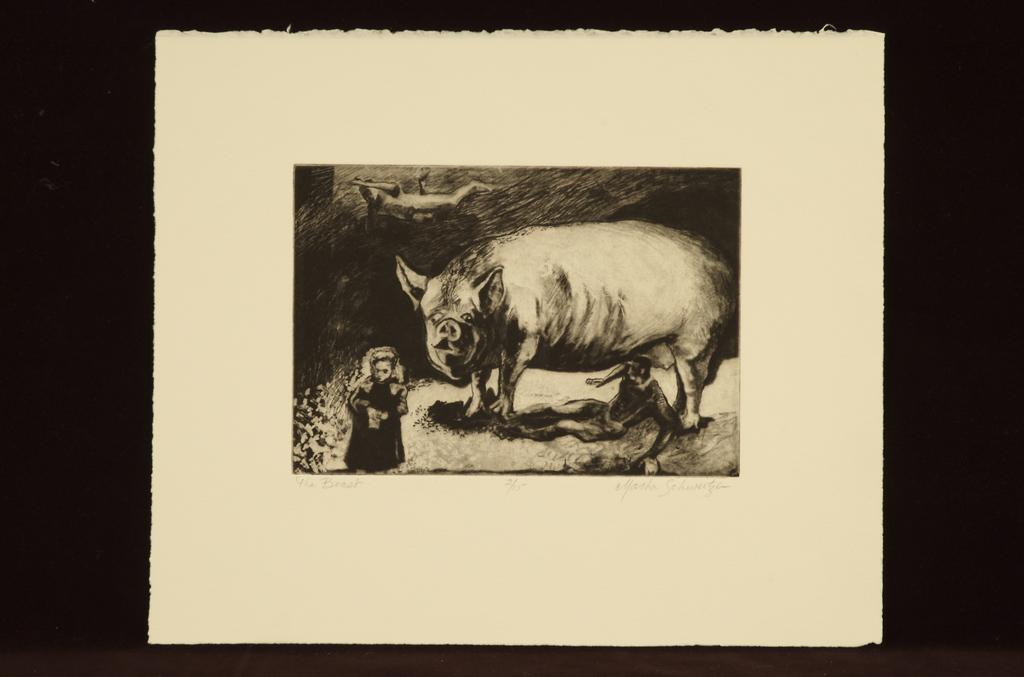What is depicted on the white surface in the image? There is a painting on a white surface. Can you describe the content of the painting? The painting contains a white and black sketch. What is the subject of the sketch? The sketch features a pig. Is there anyone else in the sketch besides the pig? Yes, there is a person standing near the pig in the sketch. How does the fog affect the visibility of the news in the image? There is no fog or news present in the image; it features a painting with a sketch of a pig and a person. 